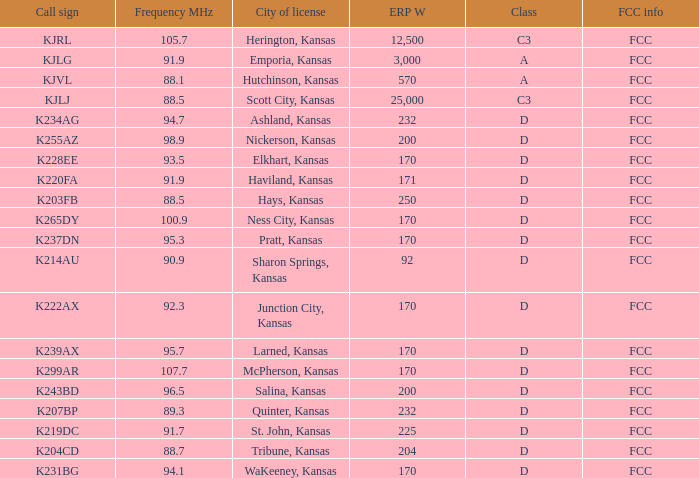ERP W that has a Class of d, and a Call sign of k299ar is what total number? 1.0. Would you be able to parse every entry in this table? {'header': ['Call sign', 'Frequency MHz', 'City of license', 'ERP W', 'Class', 'FCC info'], 'rows': [['KJRL', '105.7', 'Herington, Kansas', '12,500', 'C3', 'FCC'], ['KJLG', '91.9', 'Emporia, Kansas', '3,000', 'A', 'FCC'], ['KJVL', '88.1', 'Hutchinson, Kansas', '570', 'A', 'FCC'], ['KJLJ', '88.5', 'Scott City, Kansas', '25,000', 'C3', 'FCC'], ['K234AG', '94.7', 'Ashland, Kansas', '232', 'D', 'FCC'], ['K255AZ', '98.9', 'Nickerson, Kansas', '200', 'D', 'FCC'], ['K228EE', '93.5', 'Elkhart, Kansas', '170', 'D', 'FCC'], ['K220FA', '91.9', 'Haviland, Kansas', '171', 'D', 'FCC'], ['K203FB', '88.5', 'Hays, Kansas', '250', 'D', 'FCC'], ['K265DY', '100.9', 'Ness City, Kansas', '170', 'D', 'FCC'], ['K237DN', '95.3', 'Pratt, Kansas', '170', 'D', 'FCC'], ['K214AU', '90.9', 'Sharon Springs, Kansas', '92', 'D', 'FCC'], ['K222AX', '92.3', 'Junction City, Kansas', '170', 'D', 'FCC'], ['K239AX', '95.7', 'Larned, Kansas', '170', 'D', 'FCC'], ['K299AR', '107.7', 'McPherson, Kansas', '170', 'D', 'FCC'], ['K243BD', '96.5', 'Salina, Kansas', '200', 'D', 'FCC'], ['K207BP', '89.3', 'Quinter, Kansas', '232', 'D', 'FCC'], ['K219DC', '91.7', 'St. John, Kansas', '225', 'D', 'FCC'], ['K204CD', '88.7', 'Tribune, Kansas', '204', 'D', 'FCC'], ['K231BG', '94.1', 'WaKeeney, Kansas', '170', 'D', 'FCC']]} 